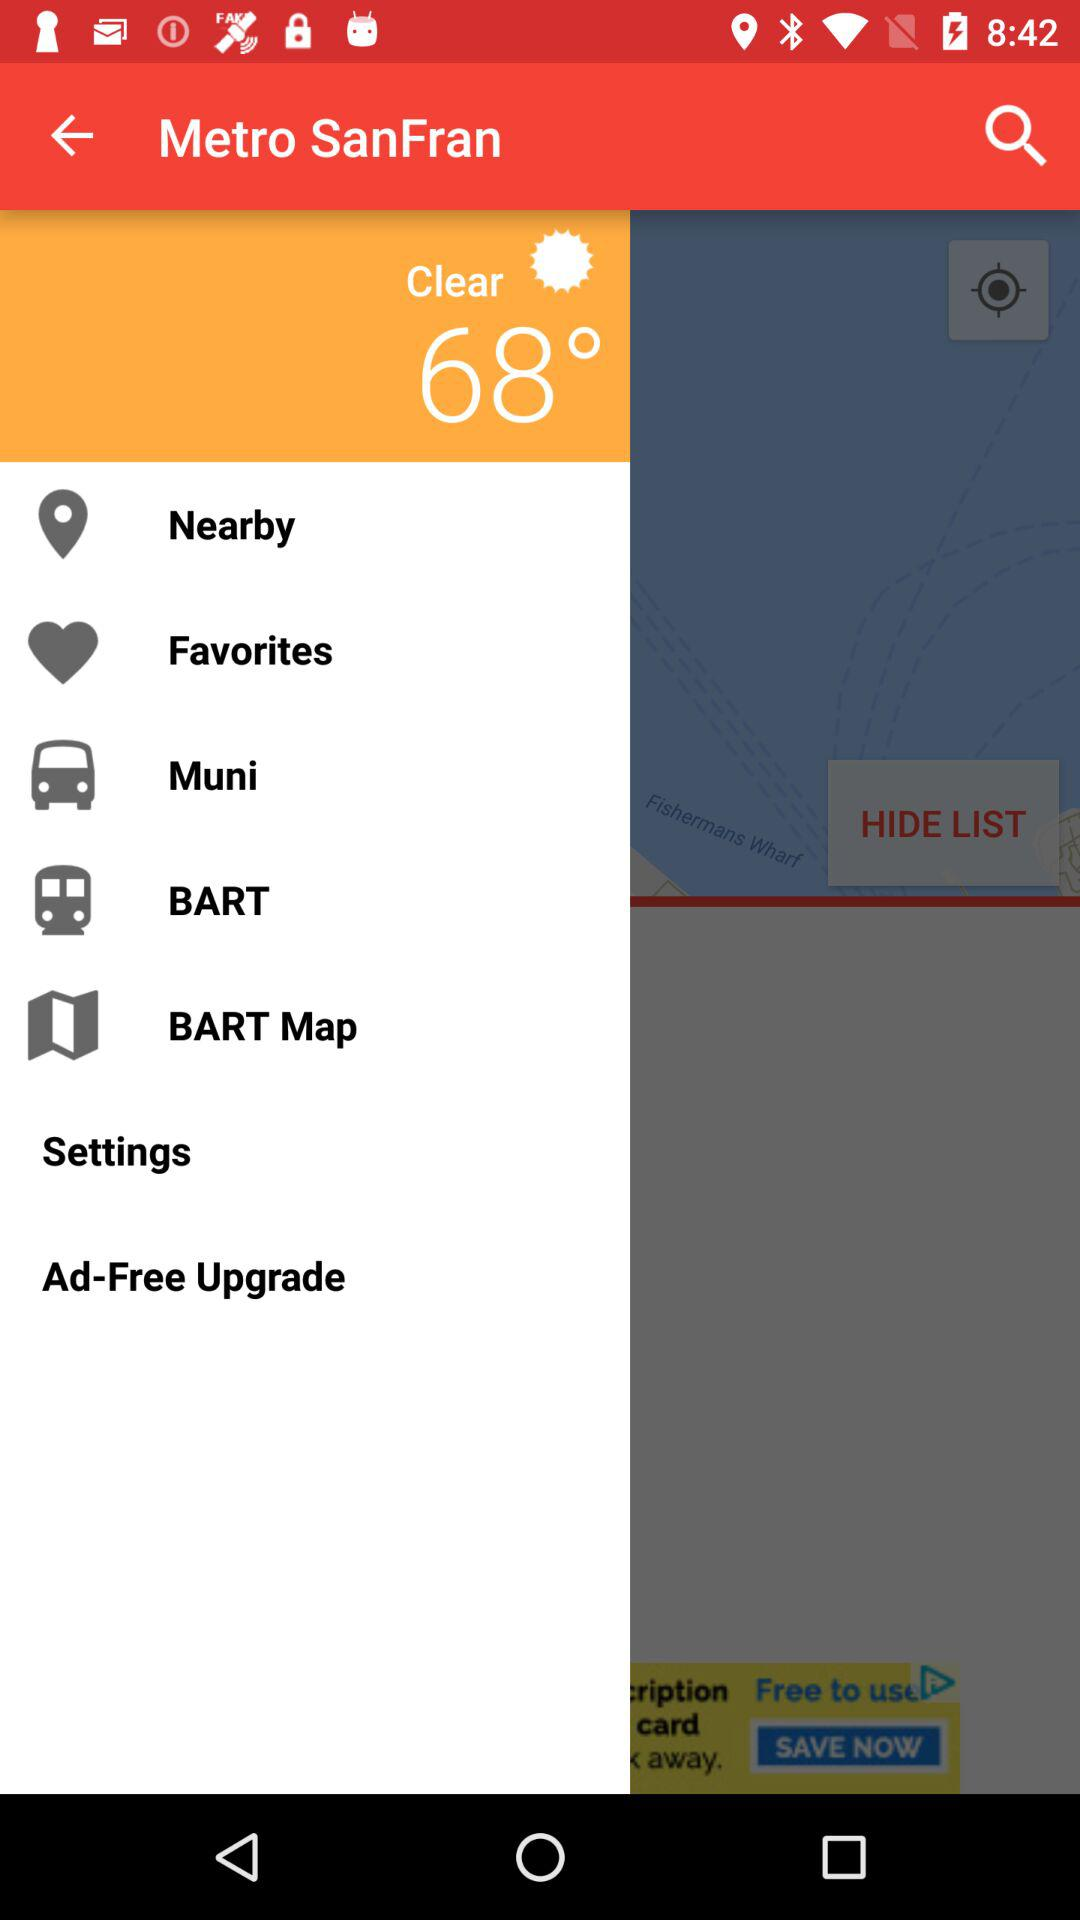What is the weather? The weather is clear. 